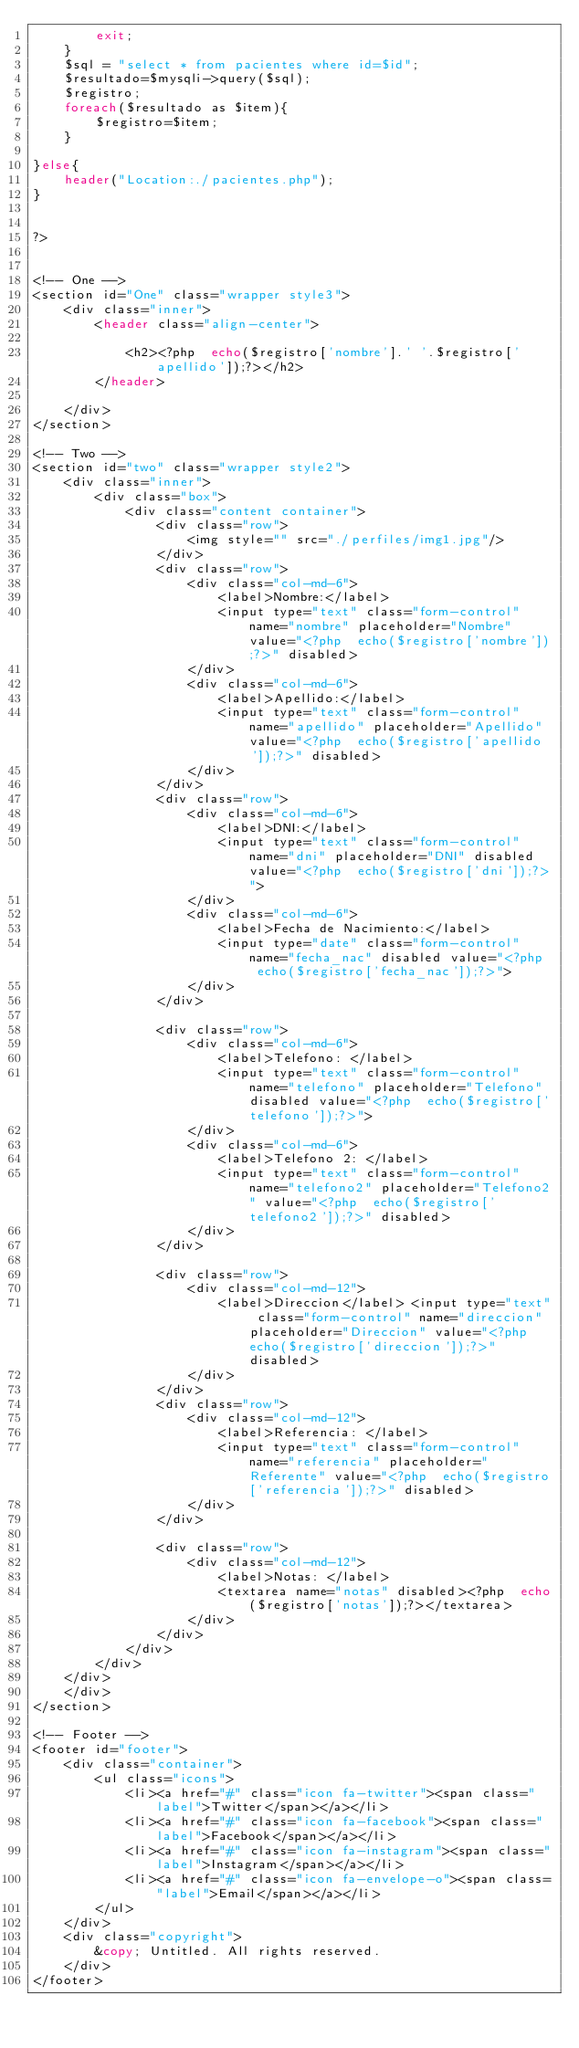Convert code to text. <code><loc_0><loc_0><loc_500><loc_500><_PHP_>        exit;
    }
    $sql = "select * from pacientes where id=$id";
    $resultado=$mysqli->query($sql);
    $registro;
    foreach($resultado as $item){
        $registro=$item;
    }

}else{
    header("Location:./pacientes.php");
}


?>


<!-- One -->
<section id="One" class="wrapper style3">
    <div class="inner">
        <header class="align-center">

            <h2><?php  echo($registro['nombre'].' '.$registro['apellido']);?></h2>
        </header>

    </div>
</section>

<!-- Two -->
<section id="two" class="wrapper style2">
    <div class="inner">
        <div class="box">
            <div class="content container">
                <div class="row">
                    <img style="" src="./perfiles/img1.jpg"/>
                </div>
                <div class="row">
                    <div class="col-md-6">
                        <label>Nombre:</label>
                        <input type="text" class="form-control" name="nombre" placeholder="Nombre" value="<?php  echo($registro['nombre']);?>" disabled>
                    </div>
                    <div class="col-md-6">
                        <label>Apellido:</label>
                        <input type="text" class="form-control" name="apellido" placeholder="Apellido" value="<?php  echo($registro['apellido']);?>" disabled>
                    </div>
                </div>
                <div class="row">
                    <div class="col-md-6">
                        <label>DNI:</label>
                        <input type="text" class="form-control" name="dni" placeholder="DNI" disabled value="<?php  echo($registro['dni']);?>">
                    </div>
                    <div class="col-md-6">
                        <label>Fecha de Nacimiento:</label>
                        <input type="date" class="form-control" name="fecha_nac" disabled value="<?php  echo($registro['fecha_nac']);?>">
                    </div>
                </div>

                <div class="row">
                    <div class="col-md-6">
                        <label>Telefono: </label>
                        <input type="text" class="form-control" name="telefono" placeholder="Telefono" disabled value="<?php  echo($registro['telefono']);?>">
                    </div>
                    <div class="col-md-6">
                        <label>Telefono 2: </label>
                        <input type="text" class="form-control" name="telefono2" placeholder="Telefono2" value="<?php  echo($registro['telefono2']);?>" disabled>
                    </div>
                </div>

                <div class="row">
                    <div class="col-md-12">
                        <label>Direccion</label> <input type="text" class="form-control" name="direccion" placeholder="Direccion" value="<?php  echo($registro['direccion']);?>" disabled>
                    </div>
                </div>
                <div class="row">
                    <div class="col-md-12">
                        <label>Referencia: </label>
                        <input type="text" class="form-control" name="referencia" placeholder="Referente" value="<?php  echo($registro['referencia']);?>" disabled>
                    </div>
                </div>

                <div class="row">
                    <div class="col-md-12">
                        <label>Notas: </label>
                        <textarea name="notas" disabled><?php  echo($registro['notas']);?></textarea>
                    </div>
                </div>
            </div>
        </div>
    </div>
    </div>
</section>

<!-- Footer -->
<footer id="footer">
    <div class="container">
        <ul class="icons">
            <li><a href="#" class="icon fa-twitter"><span class="label">Twitter</span></a></li>
            <li><a href="#" class="icon fa-facebook"><span class="label">Facebook</span></a></li>
            <li><a href="#" class="icon fa-instagram"><span class="label">Instagram</span></a></li>
            <li><a href="#" class="icon fa-envelope-o"><span class="label">Email</span></a></li>
        </ul>
    </div>
    <div class="copyright">
        &copy; Untitled. All rights reserved.
    </div>
</footer>
</code> 